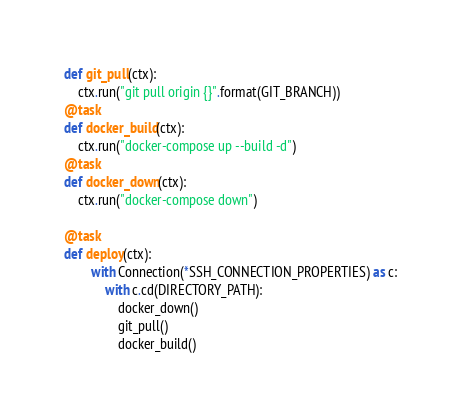<code> <loc_0><loc_0><loc_500><loc_500><_Python_>def git_pull(ctx):
    ctx.run("git pull origin {}".format(GIT_BRANCH))
@task
def docker_build(ctx):
    ctx.run("docker-compose up --build -d")
@task 
def docker_down(ctx):
    ctx.run("docker-compose down")

@task
def deploy(ctx):
        with Connection(*SSH_CONNECTION_PROPERTIES) as c:
            with c.cd(DIRECTORY_PATH):
                docker_down()
                git_pull()
                docker_build()    




</code> 